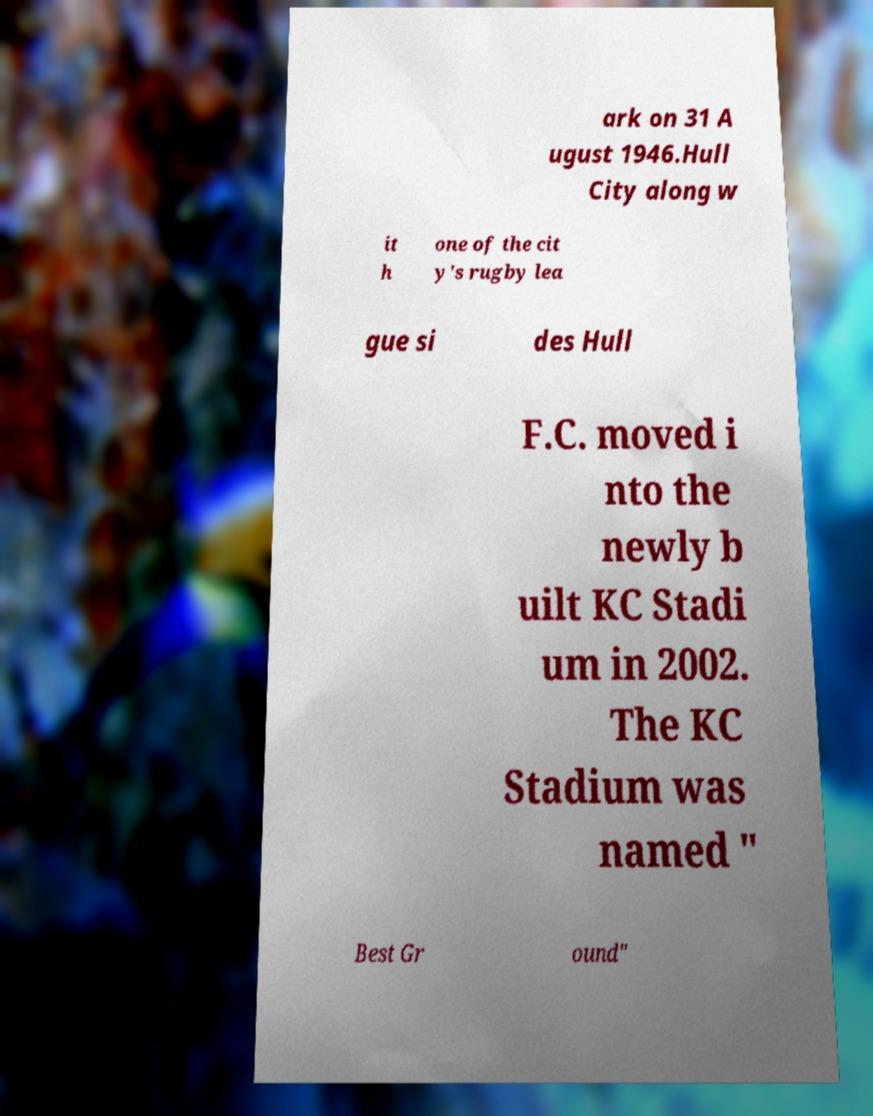I need the written content from this picture converted into text. Can you do that? ark on 31 A ugust 1946.Hull City along w it h one of the cit y's rugby lea gue si des Hull F.C. moved i nto the newly b uilt KC Stadi um in 2002. The KC Stadium was named " Best Gr ound" 